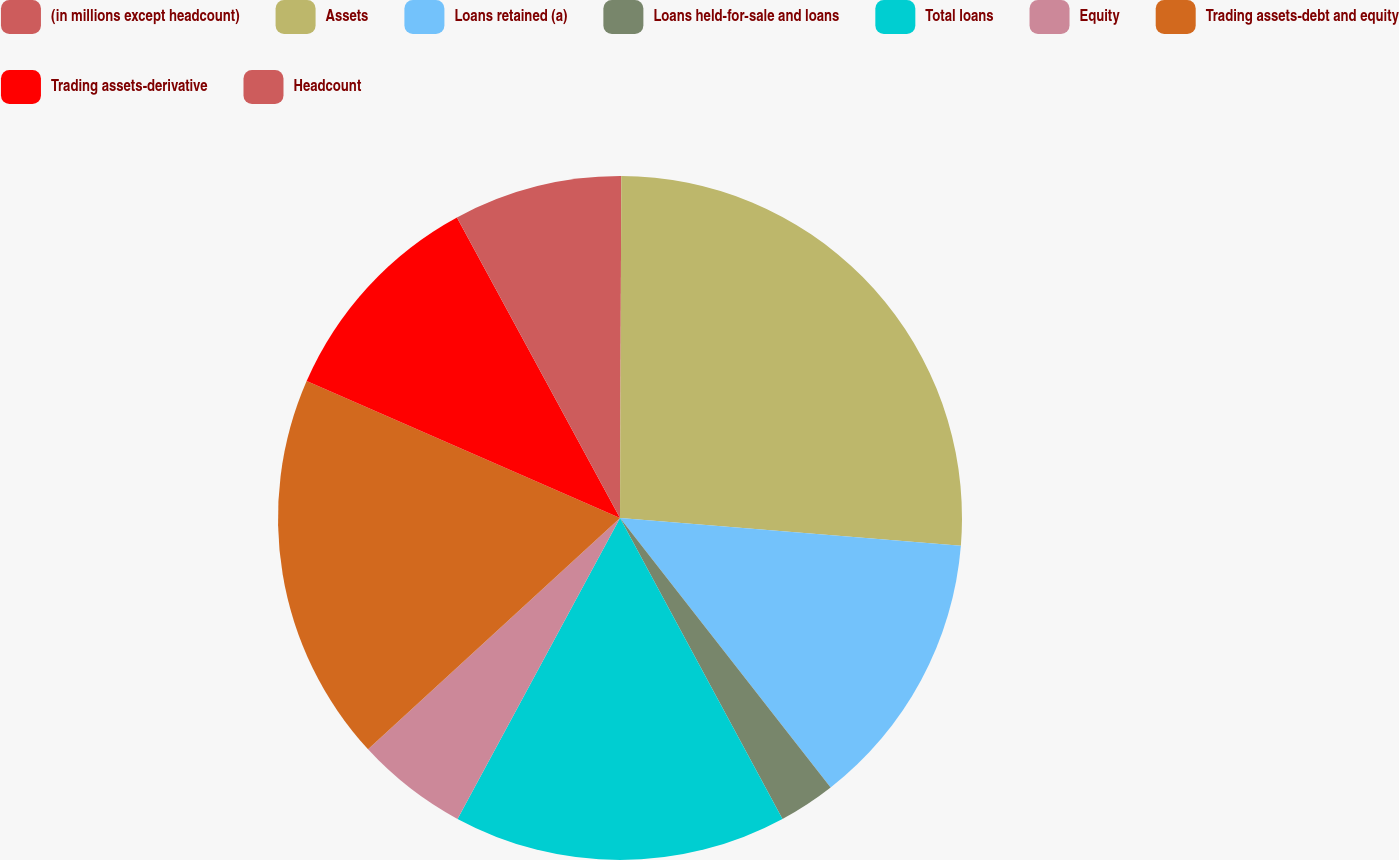<chart> <loc_0><loc_0><loc_500><loc_500><pie_chart><fcel>(in millions except headcount)<fcel>Assets<fcel>Loans retained (a)<fcel>Loans held-for-sale and loans<fcel>Total loans<fcel>Equity<fcel>Trading assets-debt and equity<fcel>Trading assets-derivative<fcel>Headcount<nl><fcel>0.06%<fcel>26.23%<fcel>13.15%<fcel>2.68%<fcel>15.76%<fcel>5.3%<fcel>18.38%<fcel>10.53%<fcel>7.91%<nl></chart> 